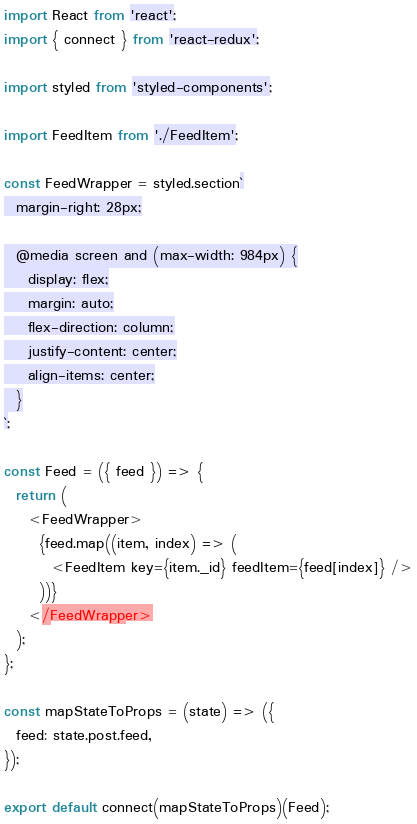Convert code to text. <code><loc_0><loc_0><loc_500><loc_500><_JavaScript_>import React from 'react';
import { connect } from 'react-redux';

import styled from 'styled-components';

import FeedItem from './FeedItem';

const FeedWrapper = styled.section`
  margin-right: 28px;

  @media screen and (max-width: 984px) {
    display: flex;
    margin: auto;
    flex-direction: column;
    justify-content: center;
    align-items: center;
  }
`;

const Feed = ({ feed }) => {
  return (
    <FeedWrapper>
      {feed.map((item, index) => (
        <FeedItem key={item._id} feedItem={feed[index]} />
      ))}
    </FeedWrapper>
  );
};

const mapStateToProps = (state) => ({
  feed: state.post.feed,
});

export default connect(mapStateToProps)(Feed);
</code> 